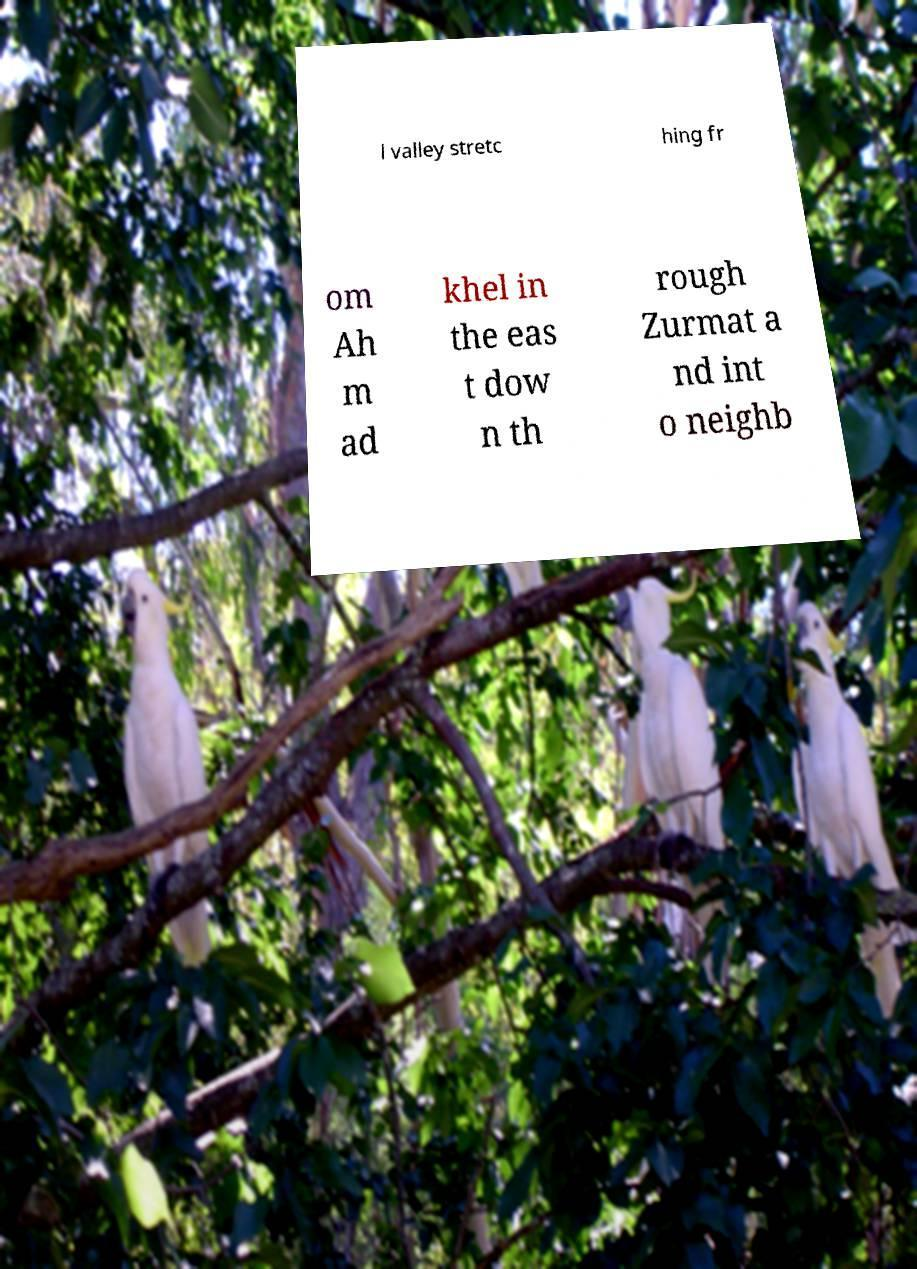Could you assist in decoding the text presented in this image and type it out clearly? l valley stretc hing fr om Ah m ad khel in the eas t dow n th rough Zurmat a nd int o neighb 